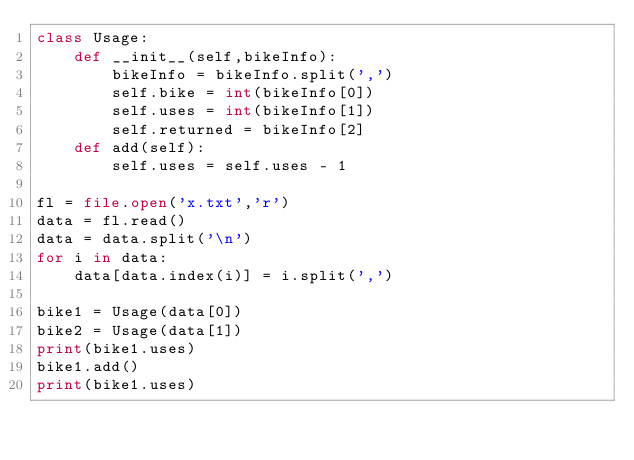Convert code to text. <code><loc_0><loc_0><loc_500><loc_500><_Python_>class Usage:
    def __init__(self,bikeInfo):
        bikeInfo = bikeInfo.split(',')
        self.bike = int(bikeInfo[0])
        self.uses = int(bikeInfo[1])
        self.returned = bikeInfo[2]
    def add(self):
        self.uses = self.uses - 1

fl = file.open('x.txt','r')
data = fl.read()
data = data.split('\n')
for i in data:
    data[data.index(i)] = i.split(',')
    
bike1 = Usage(data[0])
bike2 = Usage(data[1])
print(bike1.uses)
bike1.add()
print(bike1.uses)
</code> 